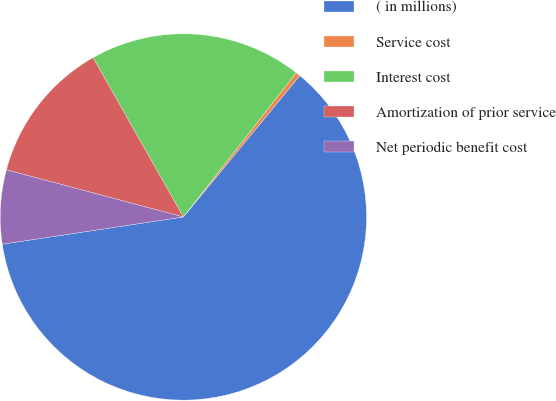Convert chart to OTSL. <chart><loc_0><loc_0><loc_500><loc_500><pie_chart><fcel>( in millions)<fcel>Service cost<fcel>Interest cost<fcel>Amortization of prior service<fcel>Net periodic benefit cost<nl><fcel>61.65%<fcel>0.4%<fcel>18.77%<fcel>12.65%<fcel>6.52%<nl></chart> 